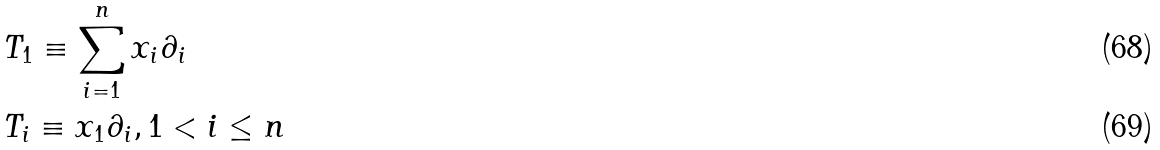<formula> <loc_0><loc_0><loc_500><loc_500>& T _ { 1 } \equiv \sum _ { i = 1 } ^ { n } x _ { i } \partial _ { i } \\ & T _ { i } \equiv x _ { 1 } \partial _ { i } , 1 < i \leq n</formula> 